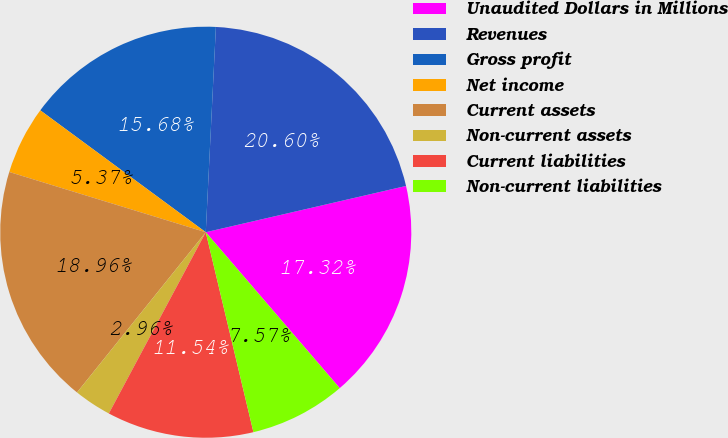Convert chart. <chart><loc_0><loc_0><loc_500><loc_500><pie_chart><fcel>Unaudited Dollars in Millions<fcel>Revenues<fcel>Gross profit<fcel>Net income<fcel>Current assets<fcel>Non-current assets<fcel>Current liabilities<fcel>Non-current liabilities<nl><fcel>17.32%<fcel>20.6%<fcel>15.68%<fcel>5.37%<fcel>18.96%<fcel>2.96%<fcel>11.54%<fcel>7.57%<nl></chart> 